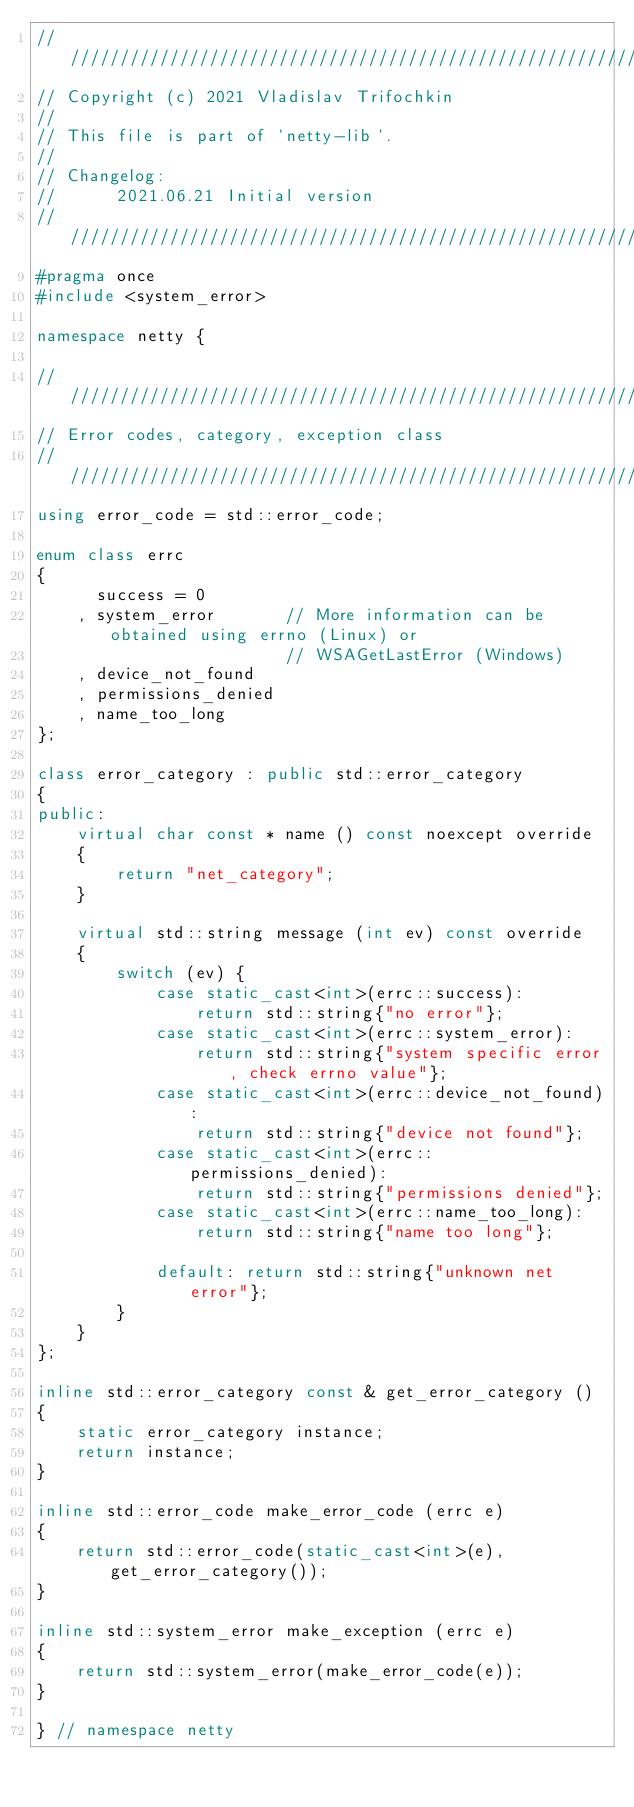Convert code to text. <code><loc_0><loc_0><loc_500><loc_500><_C++_>////////////////////////////////////////////////////////////////////////////////
// Copyright (c) 2021 Vladislav Trifochkin
//
// This file is part of `netty-lib`.
//
// Changelog:
//      2021.06.21 Initial version
////////////////////////////////////////////////////////////////////////////////
#pragma once
#include <system_error>

namespace netty {

////////////////////////////////////////////////////////////////////////////////
// Error codes, category, exception class
////////////////////////////////////////////////////////////////////////////////
using error_code = std::error_code;

enum class errc
{
      success = 0
    , system_error       // More information can be obtained using errno (Linux) or
                         // WSAGetLastError (Windows)
    , device_not_found
    , permissions_denied
    , name_too_long
};

class error_category : public std::error_category
{
public:
    virtual char const * name () const noexcept override
    {
        return "net_category";
    }

    virtual std::string message (int ev) const override
    {
        switch (ev) {
            case static_cast<int>(errc::success):
                return std::string{"no error"};
            case static_cast<int>(errc::system_error):
                return std::string{"system specific error, check errno value"};
            case static_cast<int>(errc::device_not_found):
                return std::string{"device not found"};
            case static_cast<int>(errc::permissions_denied):
                return std::string{"permissions denied"};
            case static_cast<int>(errc::name_too_long):
                return std::string{"name too long"};

            default: return std::string{"unknown net error"};
        }
    }
};

inline std::error_category const & get_error_category ()
{
    static error_category instance;
    return instance;
}

inline std::error_code make_error_code (errc e)
{
    return std::error_code(static_cast<int>(e), get_error_category());
}

inline std::system_error make_exception (errc e)
{
    return std::system_error(make_error_code(e));
}

} // namespace netty
</code> 